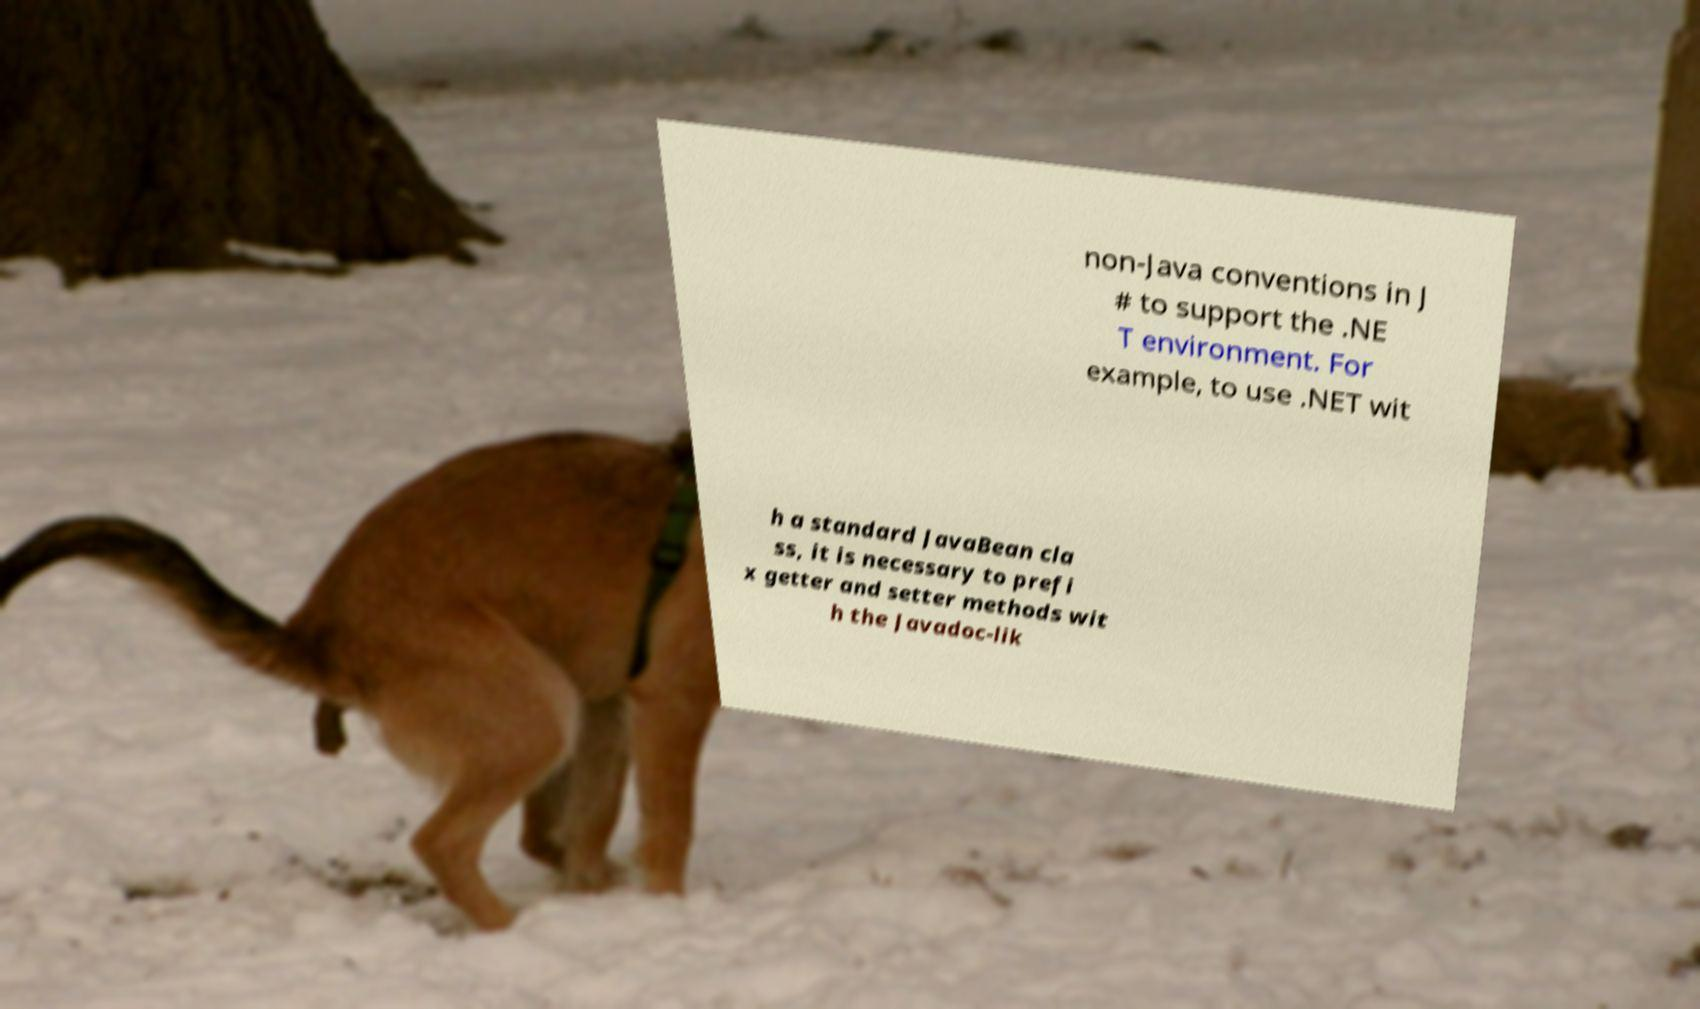Can you accurately transcribe the text from the provided image for me? non-Java conventions in J # to support the .NE T environment. For example, to use .NET wit h a standard JavaBean cla ss, it is necessary to prefi x getter and setter methods wit h the Javadoc-lik 